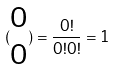<formula> <loc_0><loc_0><loc_500><loc_500>( \begin{matrix} 0 \\ 0 \end{matrix} ) = \frac { 0 ! } { 0 ! 0 ! } = 1</formula> 